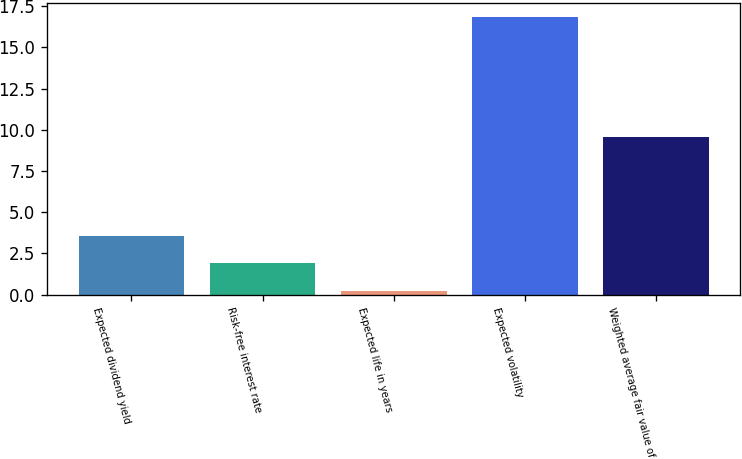Convert chart to OTSL. <chart><loc_0><loc_0><loc_500><loc_500><bar_chart><fcel>Expected dividend yield<fcel>Risk-free interest rate<fcel>Expected life in years<fcel>Expected volatility<fcel>Weighted average fair value of<nl><fcel>3.57<fcel>1.91<fcel>0.25<fcel>16.83<fcel>9.56<nl></chart> 